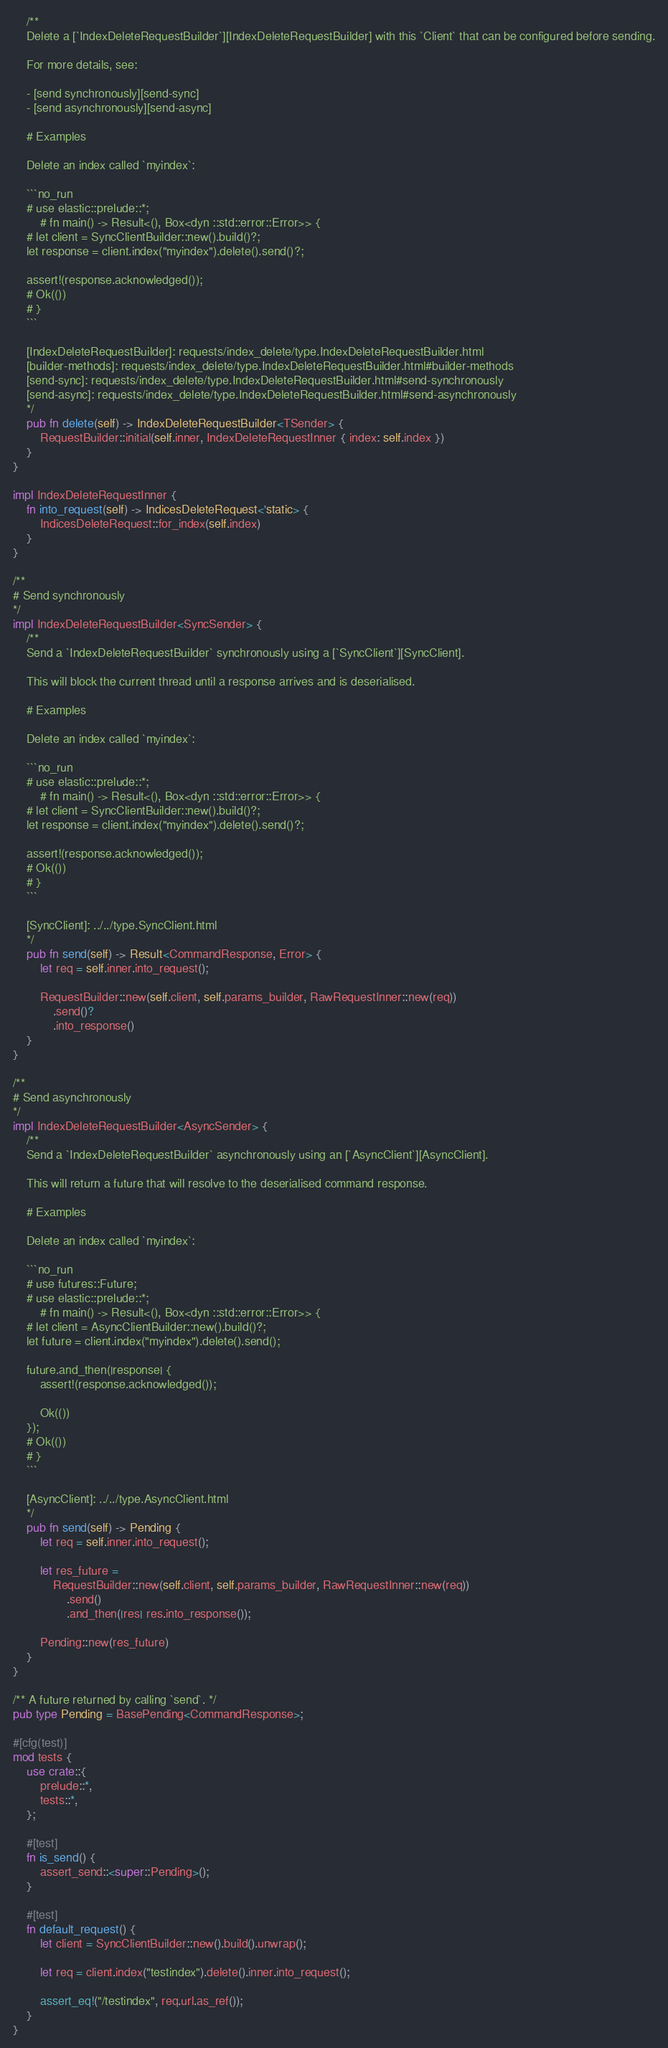<code> <loc_0><loc_0><loc_500><loc_500><_Rust_>    /**
    Delete a [`IndexDeleteRequestBuilder`][IndexDeleteRequestBuilder] with this `Client` that can be configured before sending.

    For more details, see:

    - [send synchronously][send-sync]
    - [send asynchronously][send-async]

    # Examples

    Delete an index called `myindex`:

    ```no_run
    # use elastic::prelude::*;
        # fn main() -> Result<(), Box<dyn ::std::error::Error>> {
    # let client = SyncClientBuilder::new().build()?;
    let response = client.index("myindex").delete().send()?;

    assert!(response.acknowledged());
    # Ok(())
    # }
    ```

    [IndexDeleteRequestBuilder]: requests/index_delete/type.IndexDeleteRequestBuilder.html
    [builder-methods]: requests/index_delete/type.IndexDeleteRequestBuilder.html#builder-methods
    [send-sync]: requests/index_delete/type.IndexDeleteRequestBuilder.html#send-synchronously
    [send-async]: requests/index_delete/type.IndexDeleteRequestBuilder.html#send-asynchronously
    */
    pub fn delete(self) -> IndexDeleteRequestBuilder<TSender> {
        RequestBuilder::initial(self.inner, IndexDeleteRequestInner { index: self.index })
    }
}

impl IndexDeleteRequestInner {
    fn into_request(self) -> IndicesDeleteRequest<'static> {
        IndicesDeleteRequest::for_index(self.index)
    }
}

/**
# Send synchronously
*/
impl IndexDeleteRequestBuilder<SyncSender> {
    /**
    Send a `IndexDeleteRequestBuilder` synchronously using a [`SyncClient`][SyncClient].

    This will block the current thread until a response arrives and is deserialised.

    # Examples

    Delete an index called `myindex`:

    ```no_run
    # use elastic::prelude::*;
        # fn main() -> Result<(), Box<dyn ::std::error::Error>> {
    # let client = SyncClientBuilder::new().build()?;
    let response = client.index("myindex").delete().send()?;

    assert!(response.acknowledged());
    # Ok(())
    # }
    ```

    [SyncClient]: ../../type.SyncClient.html
    */
    pub fn send(self) -> Result<CommandResponse, Error> {
        let req = self.inner.into_request();

        RequestBuilder::new(self.client, self.params_builder, RawRequestInner::new(req))
            .send()?
            .into_response()
    }
}

/**
# Send asynchronously
*/
impl IndexDeleteRequestBuilder<AsyncSender> {
    /**
    Send a `IndexDeleteRequestBuilder` asynchronously using an [`AsyncClient`][AsyncClient].

    This will return a future that will resolve to the deserialised command response.

    # Examples

    Delete an index called `myindex`:

    ```no_run
    # use futures::Future;
    # use elastic::prelude::*;
        # fn main() -> Result<(), Box<dyn ::std::error::Error>> {
    # let client = AsyncClientBuilder::new().build()?;
    let future = client.index("myindex").delete().send();

    future.and_then(|response| {
        assert!(response.acknowledged());

        Ok(())
    });
    # Ok(())
    # }
    ```

    [AsyncClient]: ../../type.AsyncClient.html
    */
    pub fn send(self) -> Pending {
        let req = self.inner.into_request();

        let res_future =
            RequestBuilder::new(self.client, self.params_builder, RawRequestInner::new(req))
                .send()
                .and_then(|res| res.into_response());

        Pending::new(res_future)
    }
}

/** A future returned by calling `send`. */
pub type Pending = BasePending<CommandResponse>;

#[cfg(test)]
mod tests {
    use crate::{
        prelude::*,
        tests::*,
    };

    #[test]
    fn is_send() {
        assert_send::<super::Pending>();
    }

    #[test]
    fn default_request() {
        let client = SyncClientBuilder::new().build().unwrap();

        let req = client.index("testindex").delete().inner.into_request();

        assert_eq!("/testindex", req.url.as_ref());
    }
}
</code> 